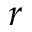<formula> <loc_0><loc_0><loc_500><loc_500>r</formula> 